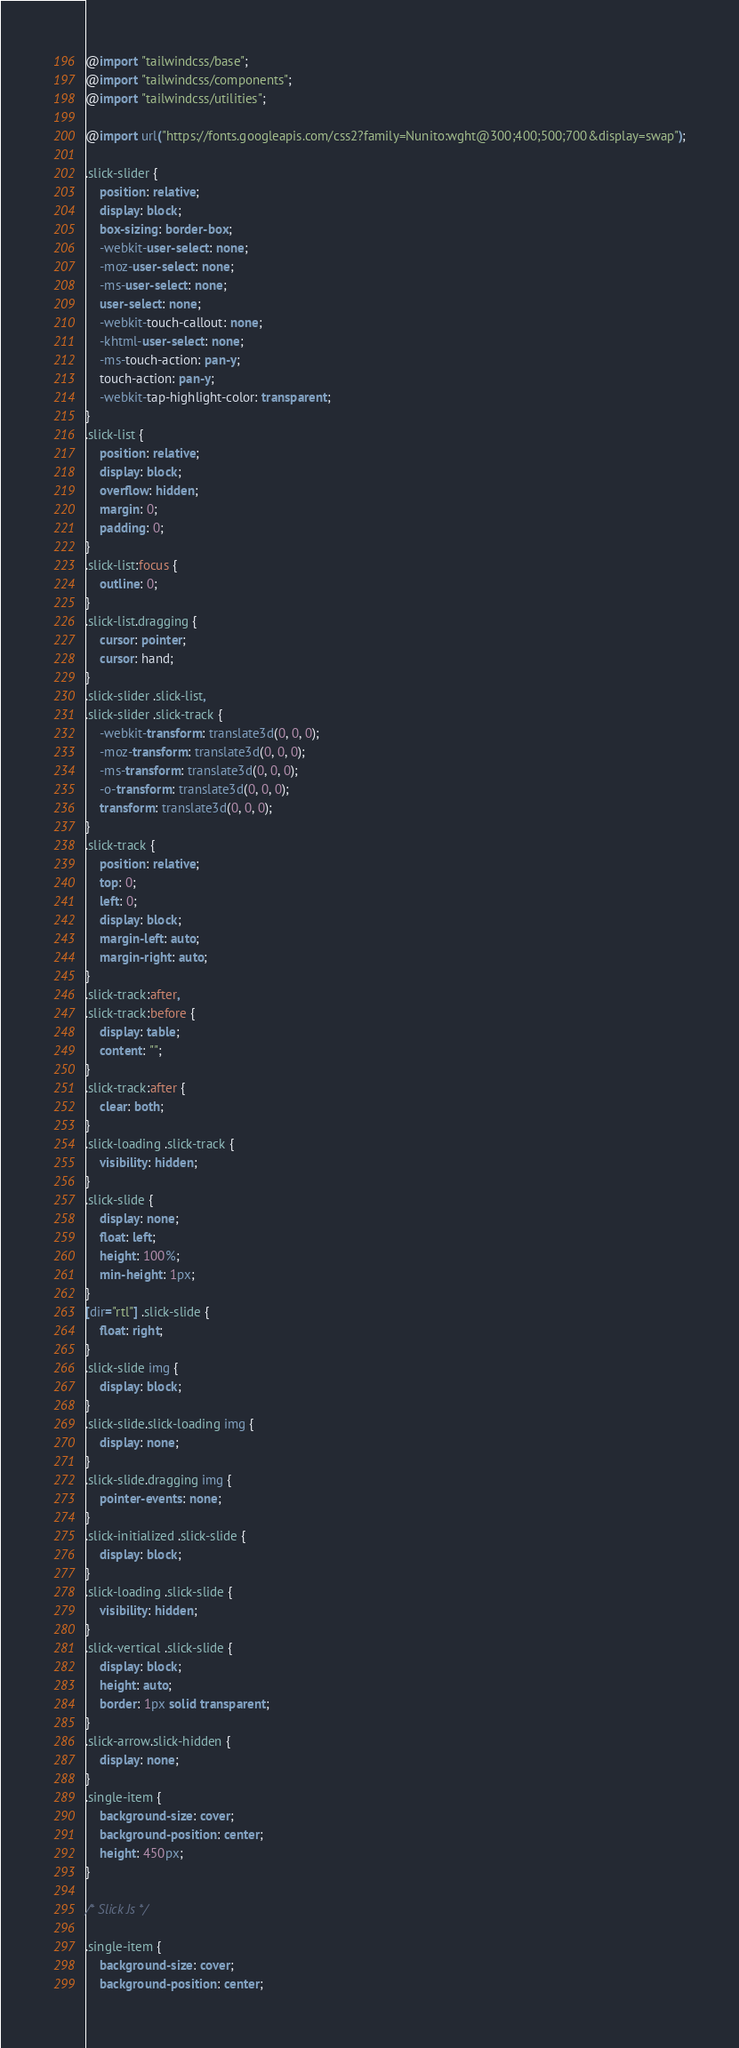<code> <loc_0><loc_0><loc_500><loc_500><_CSS_>@import "tailwindcss/base";
@import "tailwindcss/components";
@import "tailwindcss/utilities";

@import url("https://fonts.googleapis.com/css2?family=Nunito:wght@300;400;500;700&display=swap");

.slick-slider {
    position: relative;
    display: block;
    box-sizing: border-box;
    -webkit-user-select: none;
    -moz-user-select: none;
    -ms-user-select: none;
    user-select: none;
    -webkit-touch-callout: none;
    -khtml-user-select: none;
    -ms-touch-action: pan-y;
    touch-action: pan-y;
    -webkit-tap-highlight-color: transparent;
}
.slick-list {
    position: relative;
    display: block;
    overflow: hidden;
    margin: 0;
    padding: 0;
}
.slick-list:focus {
    outline: 0;
}
.slick-list.dragging {
    cursor: pointer;
    cursor: hand;
}
.slick-slider .slick-list,
.slick-slider .slick-track {
    -webkit-transform: translate3d(0, 0, 0);
    -moz-transform: translate3d(0, 0, 0);
    -ms-transform: translate3d(0, 0, 0);
    -o-transform: translate3d(0, 0, 0);
    transform: translate3d(0, 0, 0);
}
.slick-track {
    position: relative;
    top: 0;
    left: 0;
    display: block;
    margin-left: auto;
    margin-right: auto;
}
.slick-track:after,
.slick-track:before {
    display: table;
    content: "";
}
.slick-track:after {
    clear: both;
}
.slick-loading .slick-track {
    visibility: hidden;
}
.slick-slide {
    display: none;
    float: left;
    height: 100%;
    min-height: 1px;
}
[dir="rtl"] .slick-slide {
    float: right;
}
.slick-slide img {
    display: block;
}
.slick-slide.slick-loading img {
    display: none;
}
.slick-slide.dragging img {
    pointer-events: none;
}
.slick-initialized .slick-slide {
    display: block;
}
.slick-loading .slick-slide {
    visibility: hidden;
}
.slick-vertical .slick-slide {
    display: block;
    height: auto;
    border: 1px solid transparent;
}
.slick-arrow.slick-hidden {
    display: none;
}
.single-item {
    background-size: cover;
    background-position: center;
    height: 450px;
}

/* Slick Js */

.single-item {
    background-size: cover;
    background-position: center;</code> 